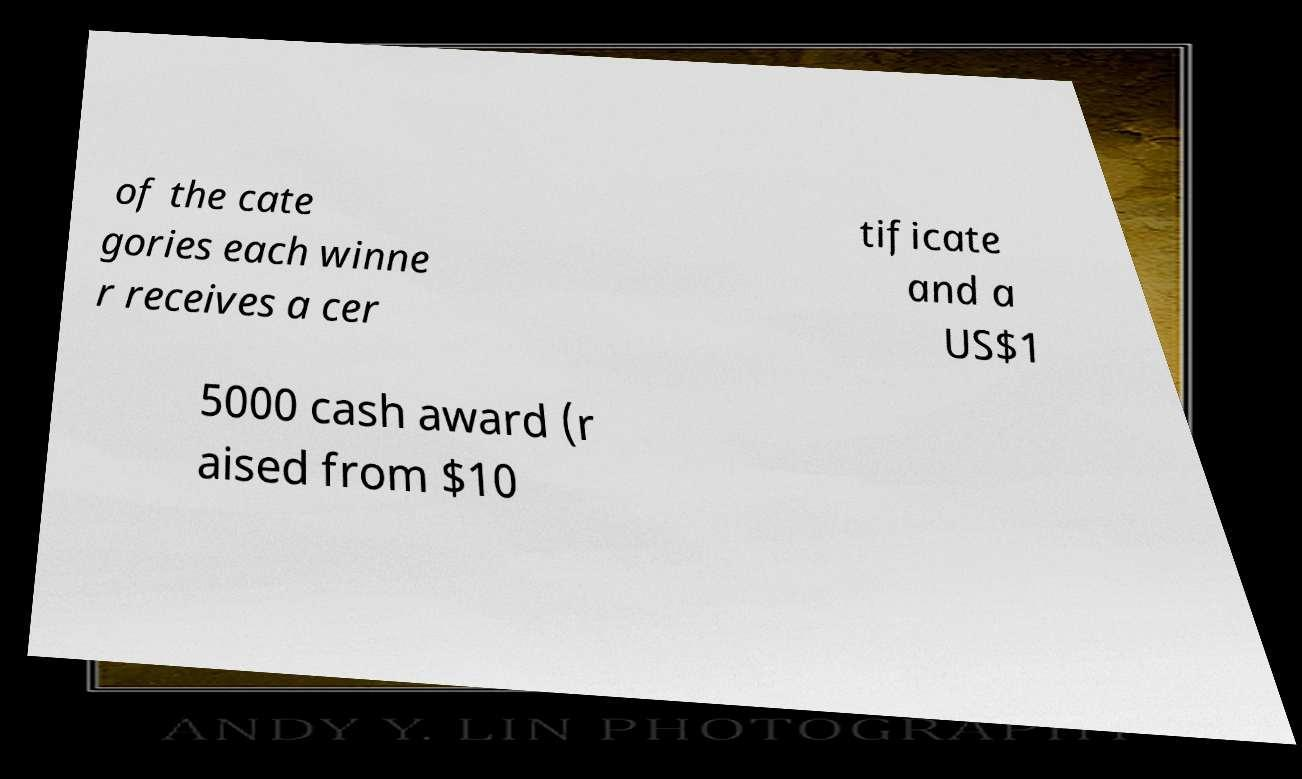Can you accurately transcribe the text from the provided image for me? of the cate gories each winne r receives a cer tificate and a US$1 5000 cash award (r aised from $10 